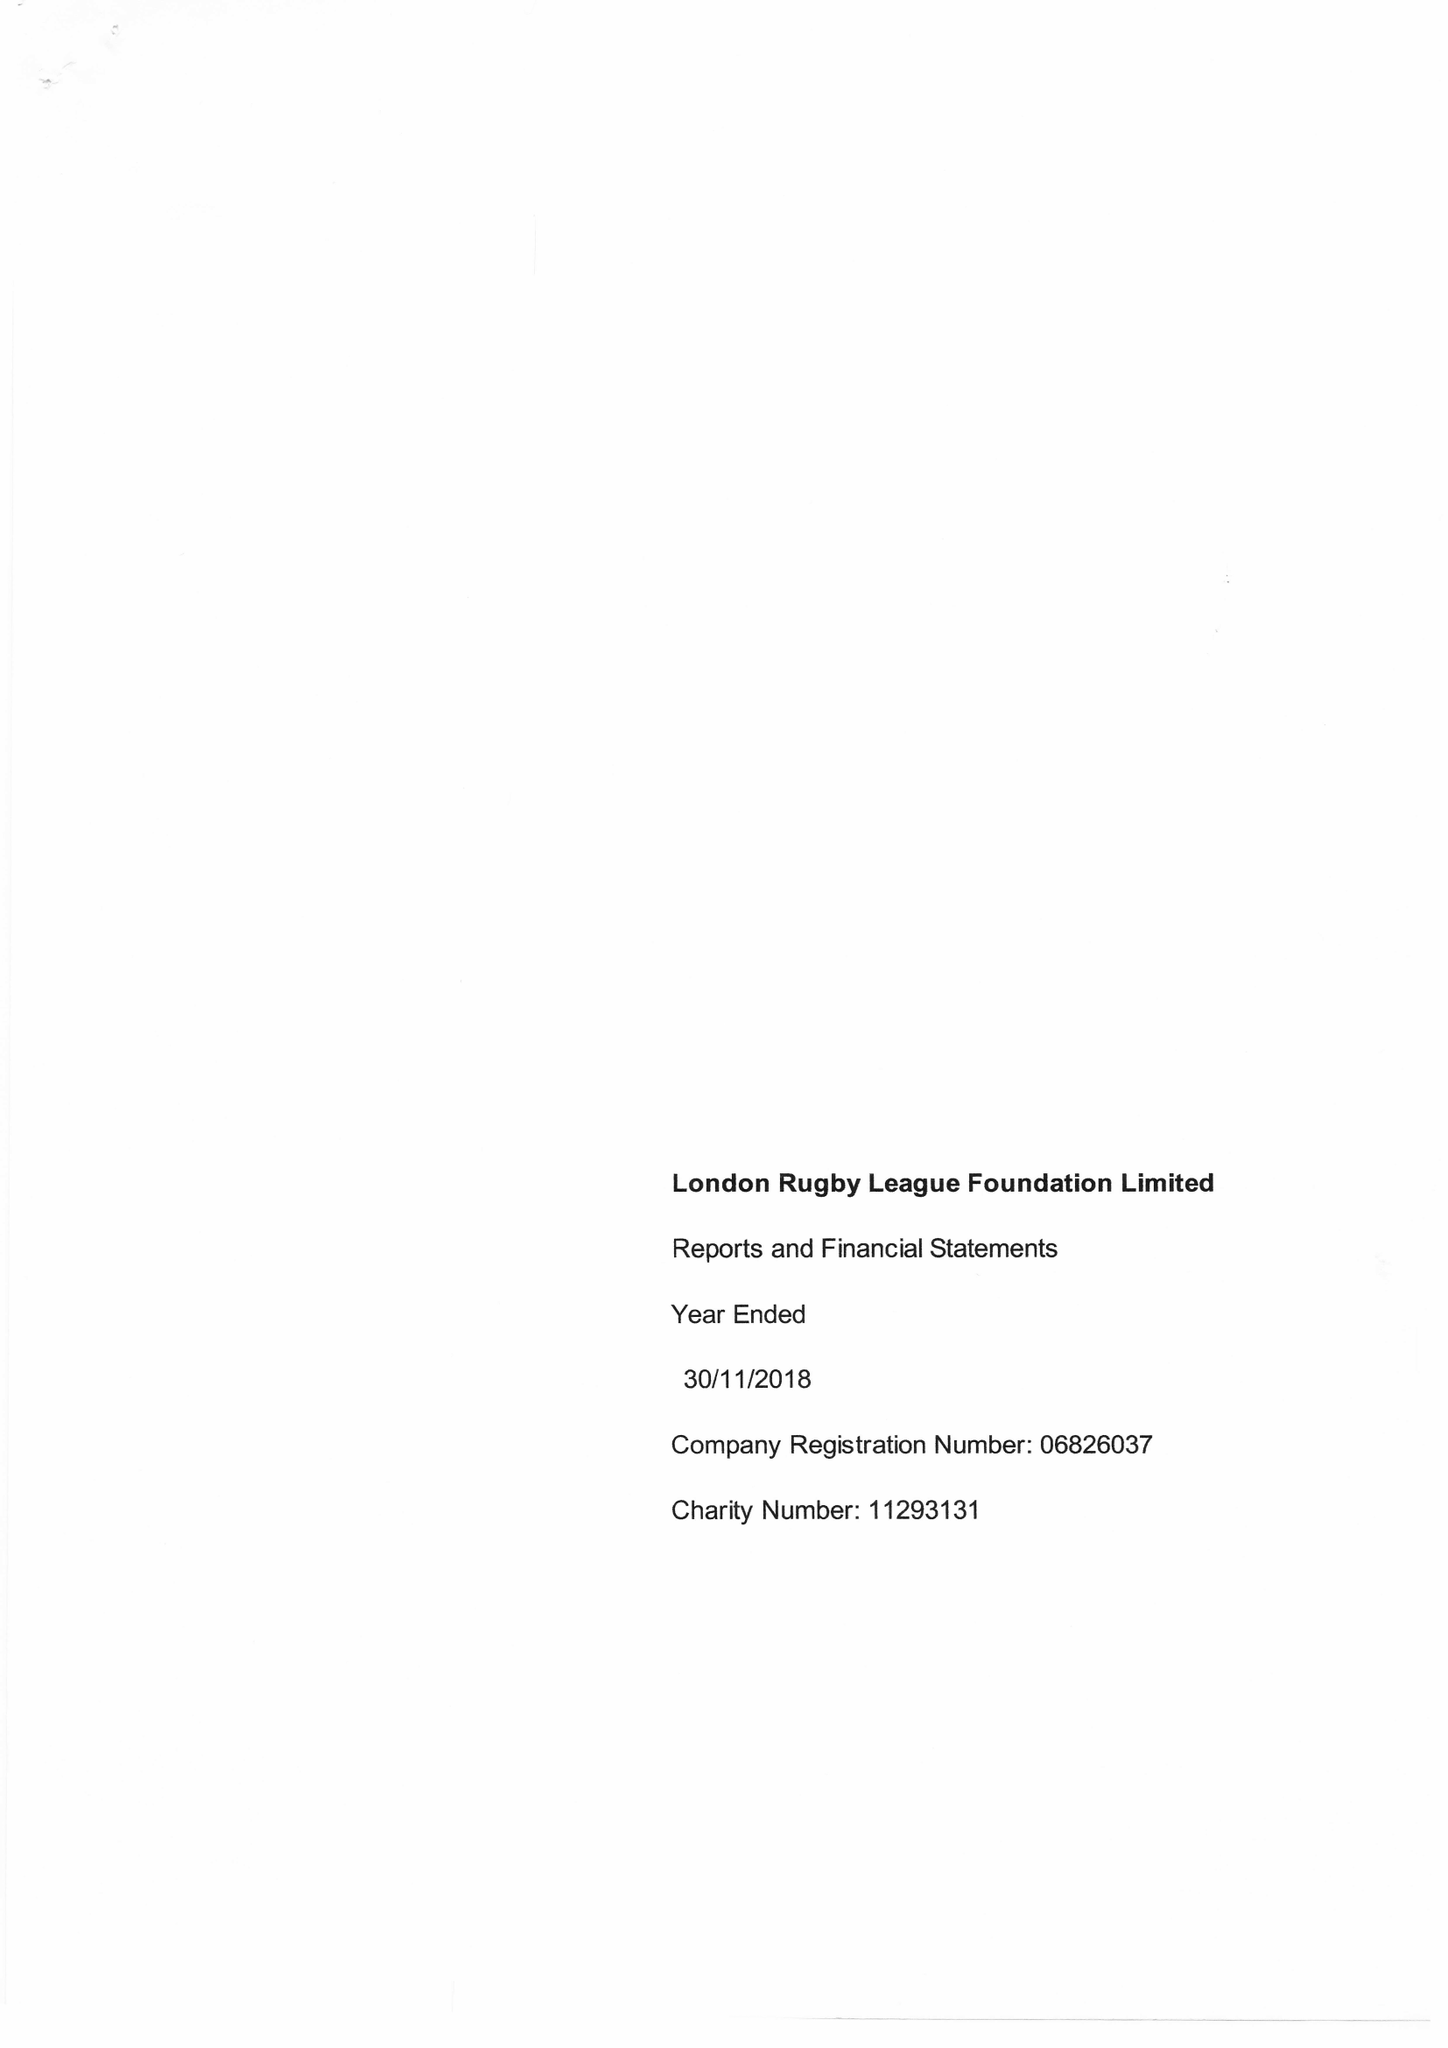What is the value for the address__street_line?
Answer the question using a single word or phrase. 190 GREAT DOVER STREET 